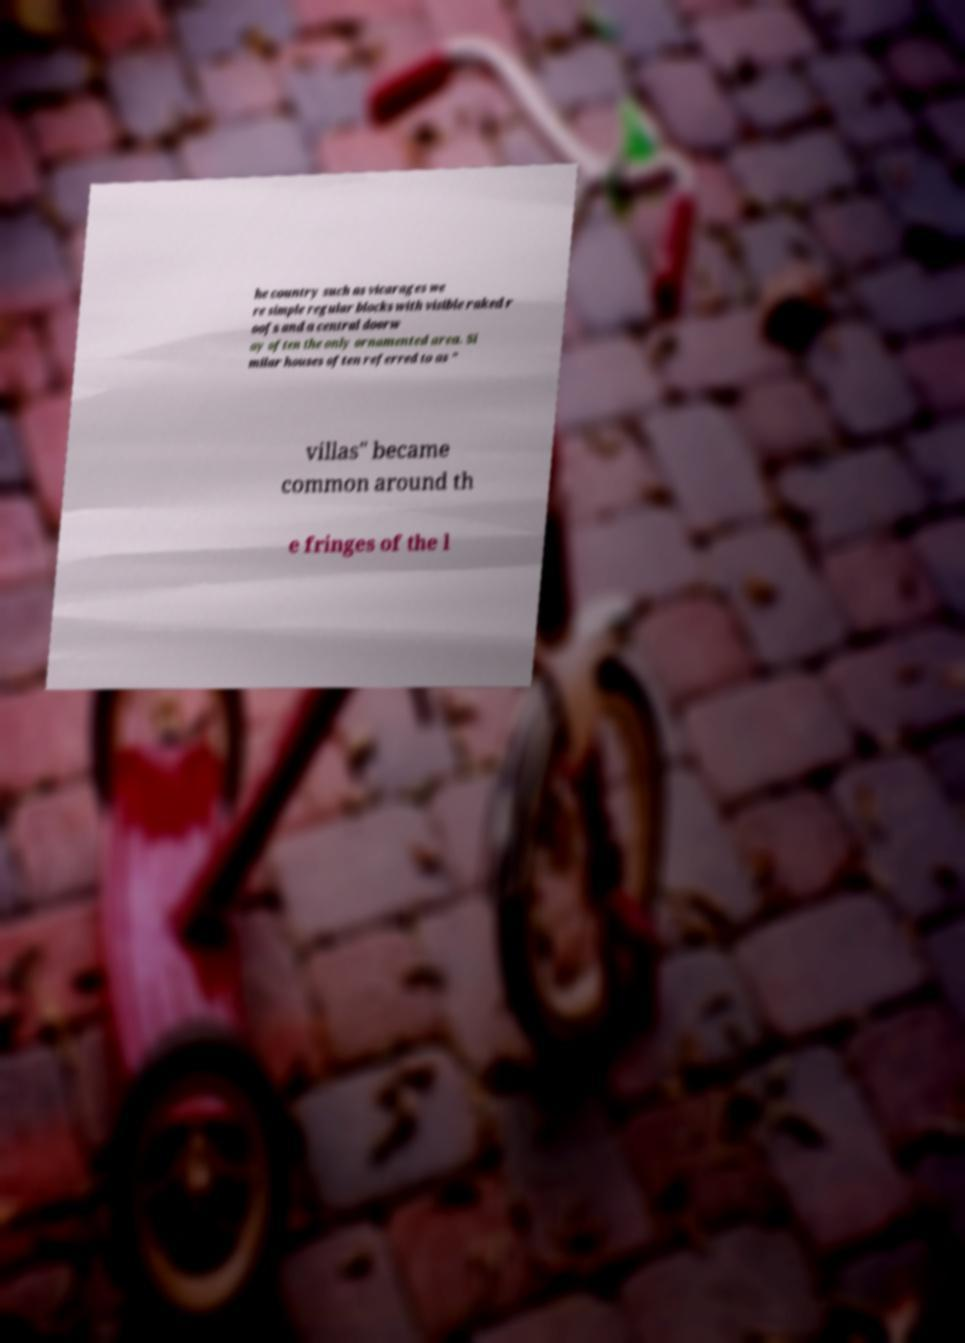Please read and relay the text visible in this image. What does it say? he country such as vicarages we re simple regular blocks with visible raked r oofs and a central doorw ay often the only ornamented area. Si milar houses often referred to as " villas" became common around th e fringes of the l 